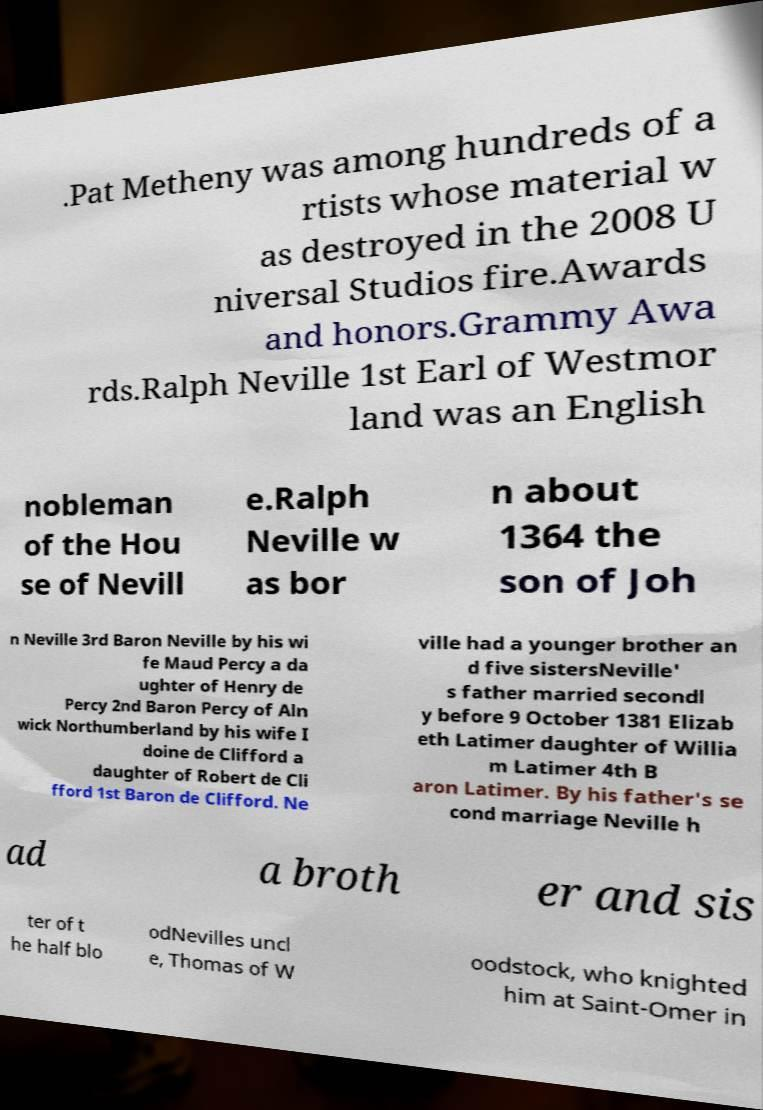Can you accurately transcribe the text from the provided image for me? .Pat Metheny was among hundreds of a rtists whose material w as destroyed in the 2008 U niversal Studios fire.Awards and honors.Grammy Awa rds.Ralph Neville 1st Earl of Westmor land was an English nobleman of the Hou se of Nevill e.Ralph Neville w as bor n about 1364 the son of Joh n Neville 3rd Baron Neville by his wi fe Maud Percy a da ughter of Henry de Percy 2nd Baron Percy of Aln wick Northumberland by his wife I doine de Clifford a daughter of Robert de Cli fford 1st Baron de Clifford. Ne ville had a younger brother an d five sistersNeville' s father married secondl y before 9 October 1381 Elizab eth Latimer daughter of Willia m Latimer 4th B aron Latimer. By his father's se cond marriage Neville h ad a broth er and sis ter of t he half blo odNevilles uncl e, Thomas of W oodstock, who knighted him at Saint-Omer in 